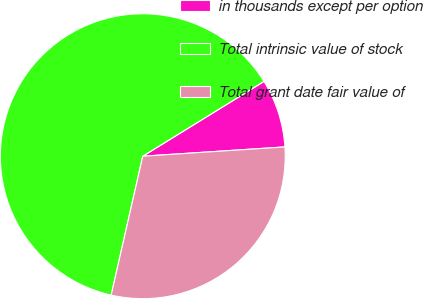<chart> <loc_0><loc_0><loc_500><loc_500><pie_chart><fcel>in thousands except per option<fcel>Total intrinsic value of stock<fcel>Total grant date fair value of<nl><fcel>7.76%<fcel>62.64%<fcel>29.6%<nl></chart> 